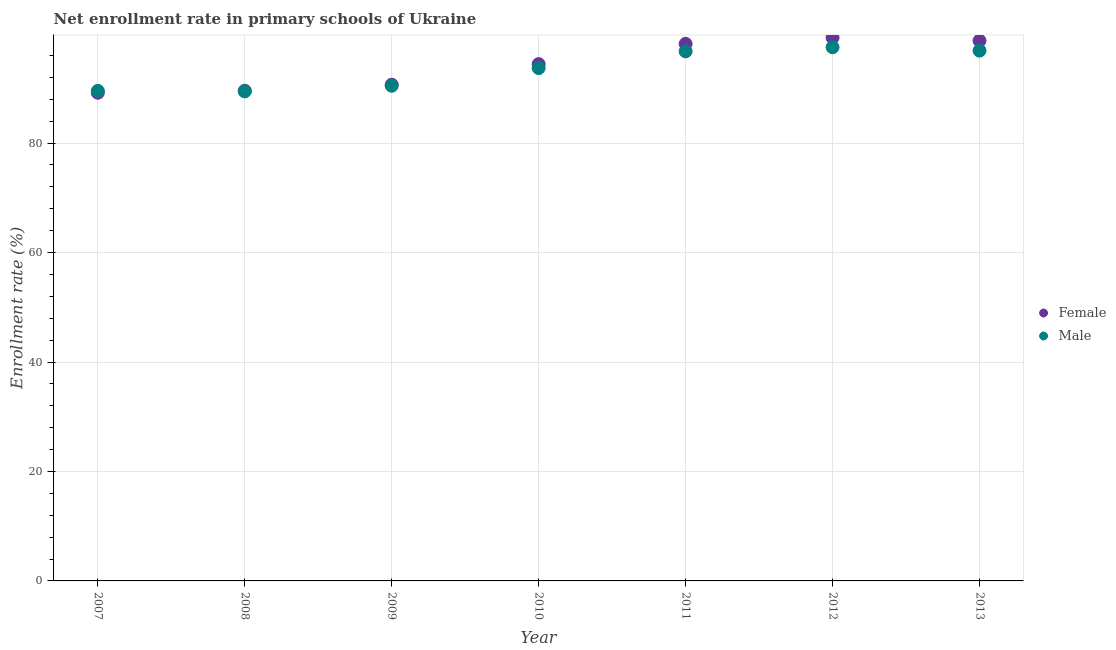How many different coloured dotlines are there?
Ensure brevity in your answer.  2. What is the enrollment rate of male students in 2013?
Give a very brief answer. 96.89. Across all years, what is the maximum enrollment rate of male students?
Make the answer very short. 97.52. Across all years, what is the minimum enrollment rate of male students?
Your response must be concise. 89.45. In which year was the enrollment rate of female students maximum?
Ensure brevity in your answer.  2012. In which year was the enrollment rate of female students minimum?
Keep it short and to the point. 2007. What is the total enrollment rate of female students in the graph?
Give a very brief answer. 659.97. What is the difference between the enrollment rate of female students in 2007 and that in 2009?
Provide a succinct answer. -1.46. What is the difference between the enrollment rate of male students in 2011 and the enrollment rate of female students in 2007?
Your answer should be compact. 7.56. What is the average enrollment rate of female students per year?
Your answer should be very brief. 94.28. In the year 2009, what is the difference between the enrollment rate of male students and enrollment rate of female students?
Make the answer very short. -0.19. What is the ratio of the enrollment rate of female students in 2010 to that in 2013?
Offer a very short reply. 0.96. What is the difference between the highest and the second highest enrollment rate of female students?
Your answer should be very brief. 0.57. What is the difference between the highest and the lowest enrollment rate of male students?
Offer a very short reply. 8.07. In how many years, is the enrollment rate of female students greater than the average enrollment rate of female students taken over all years?
Give a very brief answer. 4. Is the sum of the enrollment rate of female students in 2007 and 2010 greater than the maximum enrollment rate of male students across all years?
Your response must be concise. Yes. Does the enrollment rate of female students monotonically increase over the years?
Your answer should be compact. No. Is the enrollment rate of male students strictly greater than the enrollment rate of female students over the years?
Your response must be concise. No. Is the enrollment rate of male students strictly less than the enrollment rate of female students over the years?
Keep it short and to the point. No. How many years are there in the graph?
Keep it short and to the point. 7. Are the values on the major ticks of Y-axis written in scientific E-notation?
Make the answer very short. No. How are the legend labels stacked?
Offer a very short reply. Vertical. What is the title of the graph?
Offer a terse response. Net enrollment rate in primary schools of Ukraine. What is the label or title of the Y-axis?
Keep it short and to the point. Enrollment rate (%). What is the Enrollment rate (%) of Female in 2007?
Offer a terse response. 89.2. What is the Enrollment rate (%) in Male in 2007?
Offer a very short reply. 89.54. What is the Enrollment rate (%) in Female in 2008?
Give a very brief answer. 89.56. What is the Enrollment rate (%) of Male in 2008?
Keep it short and to the point. 89.45. What is the Enrollment rate (%) of Female in 2009?
Your answer should be compact. 90.67. What is the Enrollment rate (%) in Male in 2009?
Give a very brief answer. 90.48. What is the Enrollment rate (%) of Female in 2010?
Keep it short and to the point. 94.43. What is the Enrollment rate (%) in Male in 2010?
Provide a short and direct response. 93.71. What is the Enrollment rate (%) of Female in 2011?
Offer a very short reply. 98.13. What is the Enrollment rate (%) in Male in 2011?
Provide a succinct answer. 96.77. What is the Enrollment rate (%) in Female in 2012?
Offer a very short reply. 99.27. What is the Enrollment rate (%) in Male in 2012?
Offer a very short reply. 97.52. What is the Enrollment rate (%) in Female in 2013?
Provide a succinct answer. 98.7. What is the Enrollment rate (%) in Male in 2013?
Your response must be concise. 96.89. Across all years, what is the maximum Enrollment rate (%) of Female?
Provide a short and direct response. 99.27. Across all years, what is the maximum Enrollment rate (%) of Male?
Ensure brevity in your answer.  97.52. Across all years, what is the minimum Enrollment rate (%) in Female?
Ensure brevity in your answer.  89.2. Across all years, what is the minimum Enrollment rate (%) in Male?
Your answer should be compact. 89.45. What is the total Enrollment rate (%) of Female in the graph?
Ensure brevity in your answer.  659.97. What is the total Enrollment rate (%) in Male in the graph?
Your answer should be very brief. 654.36. What is the difference between the Enrollment rate (%) in Female in 2007 and that in 2008?
Make the answer very short. -0.36. What is the difference between the Enrollment rate (%) in Male in 2007 and that in 2008?
Offer a terse response. 0.09. What is the difference between the Enrollment rate (%) in Female in 2007 and that in 2009?
Provide a succinct answer. -1.46. What is the difference between the Enrollment rate (%) in Male in 2007 and that in 2009?
Offer a terse response. -0.94. What is the difference between the Enrollment rate (%) in Female in 2007 and that in 2010?
Your response must be concise. -5.23. What is the difference between the Enrollment rate (%) in Male in 2007 and that in 2010?
Offer a terse response. -4.17. What is the difference between the Enrollment rate (%) of Female in 2007 and that in 2011?
Give a very brief answer. -8.93. What is the difference between the Enrollment rate (%) in Male in 2007 and that in 2011?
Provide a succinct answer. -7.23. What is the difference between the Enrollment rate (%) of Female in 2007 and that in 2012?
Provide a succinct answer. -10.07. What is the difference between the Enrollment rate (%) of Male in 2007 and that in 2012?
Keep it short and to the point. -7.99. What is the difference between the Enrollment rate (%) in Female in 2007 and that in 2013?
Provide a short and direct response. -9.5. What is the difference between the Enrollment rate (%) in Male in 2007 and that in 2013?
Your answer should be very brief. -7.36. What is the difference between the Enrollment rate (%) of Female in 2008 and that in 2009?
Your answer should be very brief. -1.1. What is the difference between the Enrollment rate (%) in Male in 2008 and that in 2009?
Provide a succinct answer. -1.03. What is the difference between the Enrollment rate (%) in Female in 2008 and that in 2010?
Offer a very short reply. -4.87. What is the difference between the Enrollment rate (%) in Male in 2008 and that in 2010?
Your response must be concise. -4.26. What is the difference between the Enrollment rate (%) of Female in 2008 and that in 2011?
Offer a terse response. -8.57. What is the difference between the Enrollment rate (%) in Male in 2008 and that in 2011?
Give a very brief answer. -7.32. What is the difference between the Enrollment rate (%) of Female in 2008 and that in 2012?
Your answer should be compact. -9.71. What is the difference between the Enrollment rate (%) in Male in 2008 and that in 2012?
Your answer should be very brief. -8.07. What is the difference between the Enrollment rate (%) in Female in 2008 and that in 2013?
Ensure brevity in your answer.  -9.14. What is the difference between the Enrollment rate (%) in Male in 2008 and that in 2013?
Ensure brevity in your answer.  -7.44. What is the difference between the Enrollment rate (%) of Female in 2009 and that in 2010?
Provide a short and direct response. -3.76. What is the difference between the Enrollment rate (%) of Male in 2009 and that in 2010?
Your answer should be compact. -3.23. What is the difference between the Enrollment rate (%) in Female in 2009 and that in 2011?
Make the answer very short. -7.46. What is the difference between the Enrollment rate (%) in Male in 2009 and that in 2011?
Make the answer very short. -6.29. What is the difference between the Enrollment rate (%) in Female in 2009 and that in 2012?
Offer a very short reply. -8.6. What is the difference between the Enrollment rate (%) in Male in 2009 and that in 2012?
Ensure brevity in your answer.  -7.05. What is the difference between the Enrollment rate (%) of Female in 2009 and that in 2013?
Provide a short and direct response. -8.03. What is the difference between the Enrollment rate (%) of Male in 2009 and that in 2013?
Offer a very short reply. -6.42. What is the difference between the Enrollment rate (%) in Female in 2010 and that in 2011?
Keep it short and to the point. -3.7. What is the difference between the Enrollment rate (%) of Male in 2010 and that in 2011?
Keep it short and to the point. -3.06. What is the difference between the Enrollment rate (%) in Female in 2010 and that in 2012?
Provide a short and direct response. -4.84. What is the difference between the Enrollment rate (%) of Male in 2010 and that in 2012?
Make the answer very short. -3.81. What is the difference between the Enrollment rate (%) in Female in 2010 and that in 2013?
Your answer should be compact. -4.27. What is the difference between the Enrollment rate (%) of Male in 2010 and that in 2013?
Ensure brevity in your answer.  -3.18. What is the difference between the Enrollment rate (%) in Female in 2011 and that in 2012?
Your answer should be compact. -1.14. What is the difference between the Enrollment rate (%) of Male in 2011 and that in 2012?
Provide a short and direct response. -0.76. What is the difference between the Enrollment rate (%) of Female in 2011 and that in 2013?
Your answer should be compact. -0.57. What is the difference between the Enrollment rate (%) of Male in 2011 and that in 2013?
Provide a short and direct response. -0.13. What is the difference between the Enrollment rate (%) in Female in 2012 and that in 2013?
Offer a terse response. 0.57. What is the difference between the Enrollment rate (%) of Male in 2012 and that in 2013?
Offer a very short reply. 0.63. What is the difference between the Enrollment rate (%) in Female in 2007 and the Enrollment rate (%) in Male in 2008?
Keep it short and to the point. -0.25. What is the difference between the Enrollment rate (%) in Female in 2007 and the Enrollment rate (%) in Male in 2009?
Keep it short and to the point. -1.27. What is the difference between the Enrollment rate (%) of Female in 2007 and the Enrollment rate (%) of Male in 2010?
Ensure brevity in your answer.  -4.51. What is the difference between the Enrollment rate (%) of Female in 2007 and the Enrollment rate (%) of Male in 2011?
Offer a terse response. -7.56. What is the difference between the Enrollment rate (%) in Female in 2007 and the Enrollment rate (%) in Male in 2012?
Keep it short and to the point. -8.32. What is the difference between the Enrollment rate (%) in Female in 2007 and the Enrollment rate (%) in Male in 2013?
Your answer should be compact. -7.69. What is the difference between the Enrollment rate (%) in Female in 2008 and the Enrollment rate (%) in Male in 2009?
Give a very brief answer. -0.91. What is the difference between the Enrollment rate (%) of Female in 2008 and the Enrollment rate (%) of Male in 2010?
Offer a very short reply. -4.15. What is the difference between the Enrollment rate (%) of Female in 2008 and the Enrollment rate (%) of Male in 2011?
Give a very brief answer. -7.2. What is the difference between the Enrollment rate (%) in Female in 2008 and the Enrollment rate (%) in Male in 2012?
Ensure brevity in your answer.  -7.96. What is the difference between the Enrollment rate (%) in Female in 2008 and the Enrollment rate (%) in Male in 2013?
Provide a short and direct response. -7.33. What is the difference between the Enrollment rate (%) in Female in 2009 and the Enrollment rate (%) in Male in 2010?
Make the answer very short. -3.04. What is the difference between the Enrollment rate (%) of Female in 2009 and the Enrollment rate (%) of Male in 2011?
Your response must be concise. -6.1. What is the difference between the Enrollment rate (%) of Female in 2009 and the Enrollment rate (%) of Male in 2012?
Give a very brief answer. -6.86. What is the difference between the Enrollment rate (%) in Female in 2009 and the Enrollment rate (%) in Male in 2013?
Offer a very short reply. -6.23. What is the difference between the Enrollment rate (%) of Female in 2010 and the Enrollment rate (%) of Male in 2011?
Offer a terse response. -2.33. What is the difference between the Enrollment rate (%) of Female in 2010 and the Enrollment rate (%) of Male in 2012?
Provide a short and direct response. -3.09. What is the difference between the Enrollment rate (%) in Female in 2010 and the Enrollment rate (%) in Male in 2013?
Ensure brevity in your answer.  -2.46. What is the difference between the Enrollment rate (%) of Female in 2011 and the Enrollment rate (%) of Male in 2012?
Keep it short and to the point. 0.61. What is the difference between the Enrollment rate (%) of Female in 2011 and the Enrollment rate (%) of Male in 2013?
Your answer should be very brief. 1.24. What is the difference between the Enrollment rate (%) of Female in 2012 and the Enrollment rate (%) of Male in 2013?
Your answer should be very brief. 2.38. What is the average Enrollment rate (%) of Female per year?
Give a very brief answer. 94.28. What is the average Enrollment rate (%) of Male per year?
Provide a succinct answer. 93.48. In the year 2007, what is the difference between the Enrollment rate (%) in Female and Enrollment rate (%) in Male?
Your answer should be very brief. -0.33. In the year 2008, what is the difference between the Enrollment rate (%) of Female and Enrollment rate (%) of Male?
Ensure brevity in your answer.  0.11. In the year 2009, what is the difference between the Enrollment rate (%) of Female and Enrollment rate (%) of Male?
Make the answer very short. 0.19. In the year 2010, what is the difference between the Enrollment rate (%) in Female and Enrollment rate (%) in Male?
Offer a very short reply. 0.72. In the year 2011, what is the difference between the Enrollment rate (%) of Female and Enrollment rate (%) of Male?
Your answer should be very brief. 1.36. In the year 2012, what is the difference between the Enrollment rate (%) in Female and Enrollment rate (%) in Male?
Keep it short and to the point. 1.75. In the year 2013, what is the difference between the Enrollment rate (%) of Female and Enrollment rate (%) of Male?
Keep it short and to the point. 1.81. What is the ratio of the Enrollment rate (%) in Female in 2007 to that in 2009?
Your response must be concise. 0.98. What is the ratio of the Enrollment rate (%) in Male in 2007 to that in 2009?
Offer a very short reply. 0.99. What is the ratio of the Enrollment rate (%) in Female in 2007 to that in 2010?
Provide a short and direct response. 0.94. What is the ratio of the Enrollment rate (%) of Male in 2007 to that in 2010?
Your answer should be compact. 0.96. What is the ratio of the Enrollment rate (%) in Female in 2007 to that in 2011?
Your answer should be compact. 0.91. What is the ratio of the Enrollment rate (%) of Male in 2007 to that in 2011?
Give a very brief answer. 0.93. What is the ratio of the Enrollment rate (%) of Female in 2007 to that in 2012?
Make the answer very short. 0.9. What is the ratio of the Enrollment rate (%) in Male in 2007 to that in 2012?
Your response must be concise. 0.92. What is the ratio of the Enrollment rate (%) of Female in 2007 to that in 2013?
Offer a terse response. 0.9. What is the ratio of the Enrollment rate (%) of Male in 2007 to that in 2013?
Provide a succinct answer. 0.92. What is the ratio of the Enrollment rate (%) of Female in 2008 to that in 2009?
Provide a short and direct response. 0.99. What is the ratio of the Enrollment rate (%) in Male in 2008 to that in 2009?
Offer a very short reply. 0.99. What is the ratio of the Enrollment rate (%) of Female in 2008 to that in 2010?
Provide a short and direct response. 0.95. What is the ratio of the Enrollment rate (%) of Male in 2008 to that in 2010?
Offer a terse response. 0.95. What is the ratio of the Enrollment rate (%) of Female in 2008 to that in 2011?
Offer a terse response. 0.91. What is the ratio of the Enrollment rate (%) of Male in 2008 to that in 2011?
Your response must be concise. 0.92. What is the ratio of the Enrollment rate (%) in Female in 2008 to that in 2012?
Offer a very short reply. 0.9. What is the ratio of the Enrollment rate (%) of Male in 2008 to that in 2012?
Your response must be concise. 0.92. What is the ratio of the Enrollment rate (%) of Female in 2008 to that in 2013?
Your response must be concise. 0.91. What is the ratio of the Enrollment rate (%) in Male in 2008 to that in 2013?
Your answer should be very brief. 0.92. What is the ratio of the Enrollment rate (%) in Female in 2009 to that in 2010?
Your response must be concise. 0.96. What is the ratio of the Enrollment rate (%) of Male in 2009 to that in 2010?
Your answer should be very brief. 0.97. What is the ratio of the Enrollment rate (%) of Female in 2009 to that in 2011?
Make the answer very short. 0.92. What is the ratio of the Enrollment rate (%) of Male in 2009 to that in 2011?
Your response must be concise. 0.94. What is the ratio of the Enrollment rate (%) in Female in 2009 to that in 2012?
Make the answer very short. 0.91. What is the ratio of the Enrollment rate (%) of Male in 2009 to that in 2012?
Provide a short and direct response. 0.93. What is the ratio of the Enrollment rate (%) in Female in 2009 to that in 2013?
Keep it short and to the point. 0.92. What is the ratio of the Enrollment rate (%) in Male in 2009 to that in 2013?
Offer a terse response. 0.93. What is the ratio of the Enrollment rate (%) of Female in 2010 to that in 2011?
Provide a short and direct response. 0.96. What is the ratio of the Enrollment rate (%) of Male in 2010 to that in 2011?
Offer a terse response. 0.97. What is the ratio of the Enrollment rate (%) of Female in 2010 to that in 2012?
Keep it short and to the point. 0.95. What is the ratio of the Enrollment rate (%) of Male in 2010 to that in 2012?
Keep it short and to the point. 0.96. What is the ratio of the Enrollment rate (%) in Female in 2010 to that in 2013?
Give a very brief answer. 0.96. What is the ratio of the Enrollment rate (%) in Male in 2010 to that in 2013?
Make the answer very short. 0.97. What is the ratio of the Enrollment rate (%) of Male in 2011 to that in 2012?
Your response must be concise. 0.99. What is the ratio of the Enrollment rate (%) of Female in 2011 to that in 2013?
Give a very brief answer. 0.99. What is the ratio of the Enrollment rate (%) of Male in 2011 to that in 2013?
Provide a succinct answer. 1. What is the difference between the highest and the second highest Enrollment rate (%) of Female?
Your response must be concise. 0.57. What is the difference between the highest and the second highest Enrollment rate (%) of Male?
Keep it short and to the point. 0.63. What is the difference between the highest and the lowest Enrollment rate (%) in Female?
Make the answer very short. 10.07. What is the difference between the highest and the lowest Enrollment rate (%) in Male?
Your answer should be very brief. 8.07. 